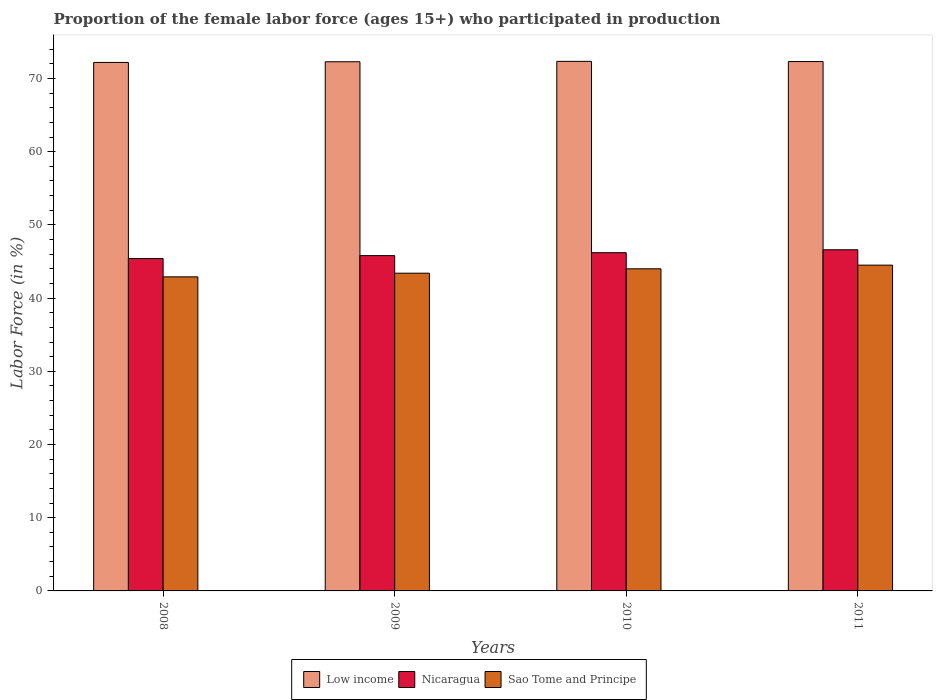How many different coloured bars are there?
Keep it short and to the point. 3. How many groups of bars are there?
Ensure brevity in your answer.  4. Are the number of bars per tick equal to the number of legend labels?
Ensure brevity in your answer.  Yes. What is the proportion of the female labor force who participated in production in Sao Tome and Principe in 2010?
Ensure brevity in your answer.  44. Across all years, what is the maximum proportion of the female labor force who participated in production in Low income?
Your answer should be very brief. 72.34. Across all years, what is the minimum proportion of the female labor force who participated in production in Low income?
Provide a succinct answer. 72.19. In which year was the proportion of the female labor force who participated in production in Sao Tome and Principe maximum?
Offer a very short reply. 2011. What is the total proportion of the female labor force who participated in production in Nicaragua in the graph?
Offer a very short reply. 184. What is the difference between the proportion of the female labor force who participated in production in Sao Tome and Principe in 2009 and that in 2010?
Your response must be concise. -0.6. What is the difference between the proportion of the female labor force who participated in production in Nicaragua in 2011 and the proportion of the female labor force who participated in production in Sao Tome and Principe in 2008?
Ensure brevity in your answer.  3.7. In the year 2008, what is the difference between the proportion of the female labor force who participated in production in Low income and proportion of the female labor force who participated in production in Sao Tome and Principe?
Your answer should be compact. 29.29. What is the ratio of the proportion of the female labor force who participated in production in Nicaragua in 2008 to that in 2011?
Your response must be concise. 0.97. Is the proportion of the female labor force who participated in production in Sao Tome and Principe in 2008 less than that in 2011?
Give a very brief answer. Yes. Is the difference between the proportion of the female labor force who participated in production in Low income in 2010 and 2011 greater than the difference between the proportion of the female labor force who participated in production in Sao Tome and Principe in 2010 and 2011?
Provide a short and direct response. Yes. What is the difference between the highest and the lowest proportion of the female labor force who participated in production in Sao Tome and Principe?
Provide a succinct answer. 1.6. Is the sum of the proportion of the female labor force who participated in production in Low income in 2009 and 2011 greater than the maximum proportion of the female labor force who participated in production in Sao Tome and Principe across all years?
Offer a very short reply. Yes. What does the 3rd bar from the left in 2011 represents?
Offer a terse response. Sao Tome and Principe. How many bars are there?
Offer a terse response. 12. How many years are there in the graph?
Offer a terse response. 4. What is the difference between two consecutive major ticks on the Y-axis?
Make the answer very short. 10. Does the graph contain grids?
Your response must be concise. No. Where does the legend appear in the graph?
Offer a very short reply. Bottom center. What is the title of the graph?
Your response must be concise. Proportion of the female labor force (ages 15+) who participated in production. What is the Labor Force (in %) of Low income in 2008?
Your answer should be compact. 72.19. What is the Labor Force (in %) of Nicaragua in 2008?
Offer a terse response. 45.4. What is the Labor Force (in %) of Sao Tome and Principe in 2008?
Provide a succinct answer. 42.9. What is the Labor Force (in %) of Low income in 2009?
Provide a short and direct response. 72.28. What is the Labor Force (in %) of Nicaragua in 2009?
Provide a succinct answer. 45.8. What is the Labor Force (in %) of Sao Tome and Principe in 2009?
Make the answer very short. 43.4. What is the Labor Force (in %) of Low income in 2010?
Provide a short and direct response. 72.34. What is the Labor Force (in %) in Nicaragua in 2010?
Your response must be concise. 46.2. What is the Labor Force (in %) of Low income in 2011?
Provide a short and direct response. 72.31. What is the Labor Force (in %) of Nicaragua in 2011?
Ensure brevity in your answer.  46.6. What is the Labor Force (in %) in Sao Tome and Principe in 2011?
Provide a short and direct response. 44.5. Across all years, what is the maximum Labor Force (in %) in Low income?
Your answer should be very brief. 72.34. Across all years, what is the maximum Labor Force (in %) in Nicaragua?
Ensure brevity in your answer.  46.6. Across all years, what is the maximum Labor Force (in %) of Sao Tome and Principe?
Your answer should be very brief. 44.5. Across all years, what is the minimum Labor Force (in %) of Low income?
Your response must be concise. 72.19. Across all years, what is the minimum Labor Force (in %) in Nicaragua?
Ensure brevity in your answer.  45.4. Across all years, what is the minimum Labor Force (in %) in Sao Tome and Principe?
Offer a terse response. 42.9. What is the total Labor Force (in %) in Low income in the graph?
Offer a very short reply. 289.11. What is the total Labor Force (in %) in Nicaragua in the graph?
Make the answer very short. 184. What is the total Labor Force (in %) of Sao Tome and Principe in the graph?
Keep it short and to the point. 174.8. What is the difference between the Labor Force (in %) in Low income in 2008 and that in 2009?
Your answer should be compact. -0.09. What is the difference between the Labor Force (in %) in Sao Tome and Principe in 2008 and that in 2009?
Make the answer very short. -0.5. What is the difference between the Labor Force (in %) of Low income in 2008 and that in 2010?
Your answer should be very brief. -0.15. What is the difference between the Labor Force (in %) in Low income in 2008 and that in 2011?
Offer a terse response. -0.12. What is the difference between the Labor Force (in %) in Low income in 2009 and that in 2010?
Make the answer very short. -0.06. What is the difference between the Labor Force (in %) of Nicaragua in 2009 and that in 2010?
Provide a succinct answer. -0.4. What is the difference between the Labor Force (in %) in Sao Tome and Principe in 2009 and that in 2010?
Keep it short and to the point. -0.6. What is the difference between the Labor Force (in %) of Low income in 2009 and that in 2011?
Give a very brief answer. -0.03. What is the difference between the Labor Force (in %) of Low income in 2010 and that in 2011?
Provide a succinct answer. 0.03. What is the difference between the Labor Force (in %) of Low income in 2008 and the Labor Force (in %) of Nicaragua in 2009?
Offer a very short reply. 26.39. What is the difference between the Labor Force (in %) of Low income in 2008 and the Labor Force (in %) of Sao Tome and Principe in 2009?
Give a very brief answer. 28.79. What is the difference between the Labor Force (in %) of Low income in 2008 and the Labor Force (in %) of Nicaragua in 2010?
Offer a very short reply. 25.99. What is the difference between the Labor Force (in %) of Low income in 2008 and the Labor Force (in %) of Sao Tome and Principe in 2010?
Give a very brief answer. 28.19. What is the difference between the Labor Force (in %) of Nicaragua in 2008 and the Labor Force (in %) of Sao Tome and Principe in 2010?
Your answer should be compact. 1.4. What is the difference between the Labor Force (in %) of Low income in 2008 and the Labor Force (in %) of Nicaragua in 2011?
Provide a short and direct response. 25.59. What is the difference between the Labor Force (in %) in Low income in 2008 and the Labor Force (in %) in Sao Tome and Principe in 2011?
Give a very brief answer. 27.69. What is the difference between the Labor Force (in %) in Nicaragua in 2008 and the Labor Force (in %) in Sao Tome and Principe in 2011?
Make the answer very short. 0.9. What is the difference between the Labor Force (in %) in Low income in 2009 and the Labor Force (in %) in Nicaragua in 2010?
Your answer should be very brief. 26.08. What is the difference between the Labor Force (in %) of Low income in 2009 and the Labor Force (in %) of Sao Tome and Principe in 2010?
Keep it short and to the point. 28.28. What is the difference between the Labor Force (in %) of Low income in 2009 and the Labor Force (in %) of Nicaragua in 2011?
Offer a terse response. 25.68. What is the difference between the Labor Force (in %) in Low income in 2009 and the Labor Force (in %) in Sao Tome and Principe in 2011?
Give a very brief answer. 27.78. What is the difference between the Labor Force (in %) of Nicaragua in 2009 and the Labor Force (in %) of Sao Tome and Principe in 2011?
Offer a terse response. 1.3. What is the difference between the Labor Force (in %) of Low income in 2010 and the Labor Force (in %) of Nicaragua in 2011?
Make the answer very short. 25.74. What is the difference between the Labor Force (in %) in Low income in 2010 and the Labor Force (in %) in Sao Tome and Principe in 2011?
Provide a short and direct response. 27.84. What is the difference between the Labor Force (in %) in Nicaragua in 2010 and the Labor Force (in %) in Sao Tome and Principe in 2011?
Provide a short and direct response. 1.7. What is the average Labor Force (in %) of Low income per year?
Your response must be concise. 72.28. What is the average Labor Force (in %) of Sao Tome and Principe per year?
Your response must be concise. 43.7. In the year 2008, what is the difference between the Labor Force (in %) of Low income and Labor Force (in %) of Nicaragua?
Your answer should be very brief. 26.79. In the year 2008, what is the difference between the Labor Force (in %) of Low income and Labor Force (in %) of Sao Tome and Principe?
Your answer should be compact. 29.29. In the year 2009, what is the difference between the Labor Force (in %) of Low income and Labor Force (in %) of Nicaragua?
Your response must be concise. 26.48. In the year 2009, what is the difference between the Labor Force (in %) of Low income and Labor Force (in %) of Sao Tome and Principe?
Provide a succinct answer. 28.88. In the year 2009, what is the difference between the Labor Force (in %) in Nicaragua and Labor Force (in %) in Sao Tome and Principe?
Keep it short and to the point. 2.4. In the year 2010, what is the difference between the Labor Force (in %) of Low income and Labor Force (in %) of Nicaragua?
Provide a short and direct response. 26.14. In the year 2010, what is the difference between the Labor Force (in %) in Low income and Labor Force (in %) in Sao Tome and Principe?
Give a very brief answer. 28.34. In the year 2010, what is the difference between the Labor Force (in %) of Nicaragua and Labor Force (in %) of Sao Tome and Principe?
Give a very brief answer. 2.2. In the year 2011, what is the difference between the Labor Force (in %) of Low income and Labor Force (in %) of Nicaragua?
Keep it short and to the point. 25.71. In the year 2011, what is the difference between the Labor Force (in %) in Low income and Labor Force (in %) in Sao Tome and Principe?
Ensure brevity in your answer.  27.81. What is the ratio of the Labor Force (in %) in Low income in 2008 to that in 2009?
Provide a succinct answer. 1. What is the ratio of the Labor Force (in %) in Sao Tome and Principe in 2008 to that in 2009?
Provide a short and direct response. 0.99. What is the ratio of the Labor Force (in %) of Nicaragua in 2008 to that in 2010?
Your answer should be very brief. 0.98. What is the ratio of the Labor Force (in %) of Sao Tome and Principe in 2008 to that in 2010?
Provide a succinct answer. 0.97. What is the ratio of the Labor Force (in %) of Nicaragua in 2008 to that in 2011?
Provide a short and direct response. 0.97. What is the ratio of the Labor Force (in %) in Sao Tome and Principe in 2008 to that in 2011?
Your answer should be compact. 0.96. What is the ratio of the Labor Force (in %) of Low income in 2009 to that in 2010?
Your answer should be very brief. 1. What is the ratio of the Labor Force (in %) of Sao Tome and Principe in 2009 to that in 2010?
Make the answer very short. 0.99. What is the ratio of the Labor Force (in %) of Low income in 2009 to that in 2011?
Give a very brief answer. 1. What is the ratio of the Labor Force (in %) in Nicaragua in 2009 to that in 2011?
Provide a short and direct response. 0.98. What is the ratio of the Labor Force (in %) of Sao Tome and Principe in 2009 to that in 2011?
Give a very brief answer. 0.98. What is the ratio of the Labor Force (in %) of Nicaragua in 2010 to that in 2011?
Make the answer very short. 0.99. What is the difference between the highest and the second highest Labor Force (in %) of Low income?
Provide a succinct answer. 0.03. What is the difference between the highest and the lowest Labor Force (in %) in Low income?
Your answer should be very brief. 0.15. What is the difference between the highest and the lowest Labor Force (in %) in Sao Tome and Principe?
Offer a very short reply. 1.6. 